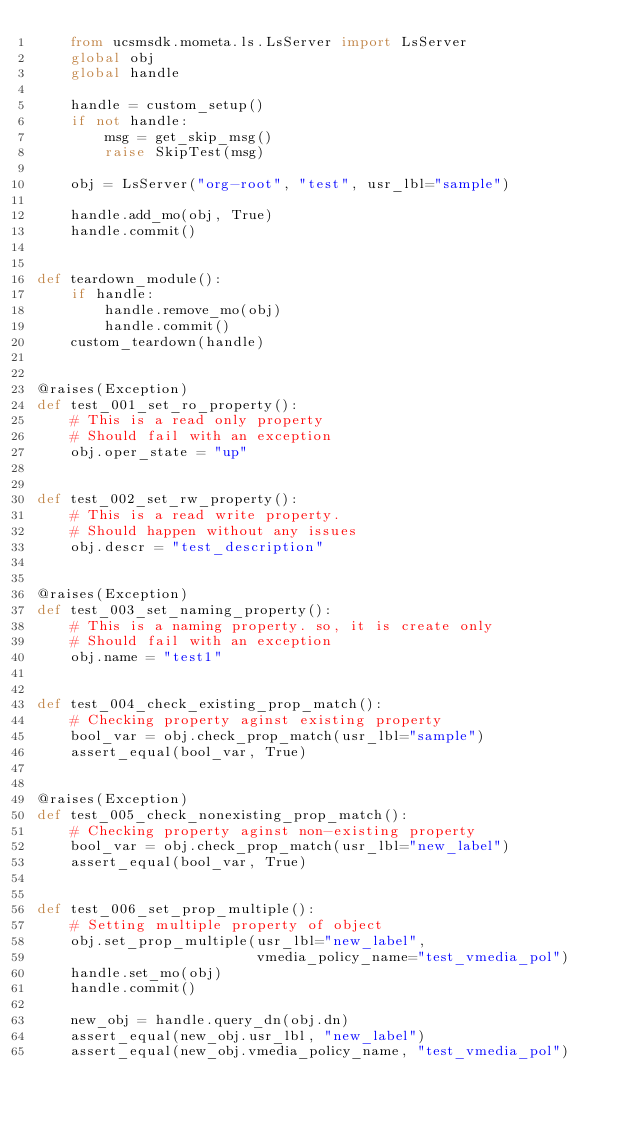<code> <loc_0><loc_0><loc_500><loc_500><_Python_>    from ucsmsdk.mometa.ls.LsServer import LsServer
    global obj
    global handle

    handle = custom_setup()
    if not handle:
        msg = get_skip_msg()
        raise SkipTest(msg)

    obj = LsServer("org-root", "test", usr_lbl="sample")

    handle.add_mo(obj, True)
    handle.commit()


def teardown_module():
    if handle:
        handle.remove_mo(obj)
        handle.commit()
    custom_teardown(handle)


@raises(Exception)
def test_001_set_ro_property():
    # This is a read only property
    # Should fail with an exception
    obj.oper_state = "up"


def test_002_set_rw_property():
    # This is a read write property.
    # Should happen without any issues
    obj.descr = "test_description"


@raises(Exception)
def test_003_set_naming_property():
    # This is a naming property. so, it is create only
    # Should fail with an exception
    obj.name = "test1"


def test_004_check_existing_prop_match():
    # Checking property aginst existing property
    bool_var = obj.check_prop_match(usr_lbl="sample")
    assert_equal(bool_var, True)


@raises(Exception)
def test_005_check_nonexisting_prop_match():
    # Checking property aginst non-existing property
    bool_var = obj.check_prop_match(usr_lbl="new_label")
    assert_equal(bool_var, True)


def test_006_set_prop_multiple():
    # Setting multiple property of object
    obj.set_prop_multiple(usr_lbl="new_label",
                          vmedia_policy_name="test_vmedia_pol")
    handle.set_mo(obj)
    handle.commit()

    new_obj = handle.query_dn(obj.dn)
    assert_equal(new_obj.usr_lbl, "new_label")
    assert_equal(new_obj.vmedia_policy_name, "test_vmedia_pol")
</code> 